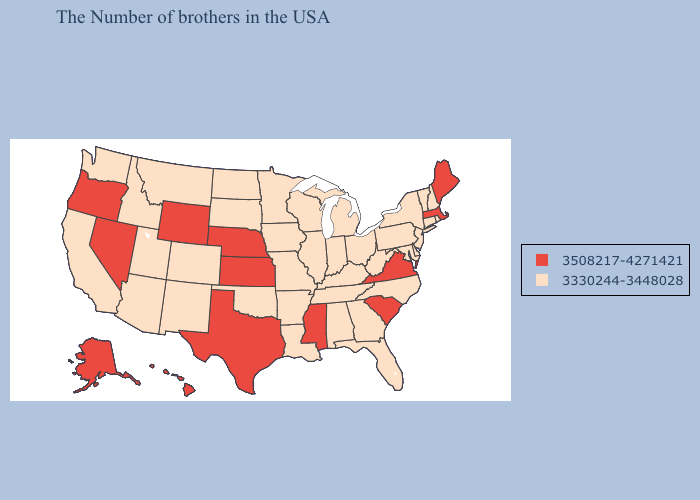Which states have the lowest value in the Northeast?
Answer briefly. Rhode Island, New Hampshire, Vermont, Connecticut, New York, New Jersey, Pennsylvania. What is the highest value in states that border Mississippi?
Quick response, please. 3330244-3448028. Does the map have missing data?
Be succinct. No. What is the highest value in the South ?
Quick response, please. 3508217-4271421. Name the states that have a value in the range 3330244-3448028?
Concise answer only. Rhode Island, New Hampshire, Vermont, Connecticut, New York, New Jersey, Delaware, Maryland, Pennsylvania, North Carolina, West Virginia, Ohio, Florida, Georgia, Michigan, Kentucky, Indiana, Alabama, Tennessee, Wisconsin, Illinois, Louisiana, Missouri, Arkansas, Minnesota, Iowa, Oklahoma, South Dakota, North Dakota, Colorado, New Mexico, Utah, Montana, Arizona, Idaho, California, Washington. Does Kansas have the lowest value in the MidWest?
Keep it brief. No. Does Washington have a lower value than Maine?
Keep it brief. Yes. Does the map have missing data?
Keep it brief. No. What is the value of Illinois?
Short answer required. 3330244-3448028. Name the states that have a value in the range 3330244-3448028?
Write a very short answer. Rhode Island, New Hampshire, Vermont, Connecticut, New York, New Jersey, Delaware, Maryland, Pennsylvania, North Carolina, West Virginia, Ohio, Florida, Georgia, Michigan, Kentucky, Indiana, Alabama, Tennessee, Wisconsin, Illinois, Louisiana, Missouri, Arkansas, Minnesota, Iowa, Oklahoma, South Dakota, North Dakota, Colorado, New Mexico, Utah, Montana, Arizona, Idaho, California, Washington. Does Vermont have the lowest value in the USA?
Answer briefly. Yes. What is the value of Iowa?
Answer briefly. 3330244-3448028. How many symbols are there in the legend?
Keep it brief. 2. Among the states that border South Carolina , which have the lowest value?
Give a very brief answer. North Carolina, Georgia. 